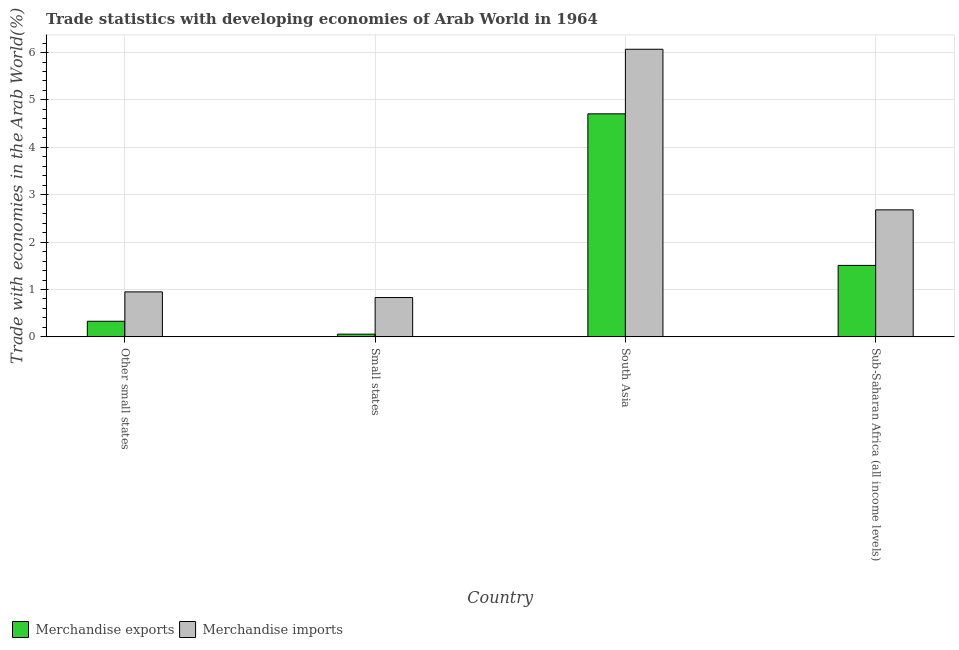How many groups of bars are there?
Provide a succinct answer. 4. How many bars are there on the 1st tick from the right?
Provide a short and direct response. 2. What is the label of the 4th group of bars from the left?
Give a very brief answer. Sub-Saharan Africa (all income levels). What is the merchandise imports in Small states?
Provide a succinct answer. 0.83. Across all countries, what is the maximum merchandise imports?
Your answer should be compact. 6.07. Across all countries, what is the minimum merchandise exports?
Ensure brevity in your answer.  0.06. In which country was the merchandise imports maximum?
Offer a very short reply. South Asia. In which country was the merchandise exports minimum?
Ensure brevity in your answer.  Small states. What is the total merchandise exports in the graph?
Keep it short and to the point. 6.6. What is the difference between the merchandise exports in Small states and that in Sub-Saharan Africa (all income levels)?
Your answer should be very brief. -1.45. What is the difference between the merchandise exports in South Asia and the merchandise imports in Other small states?
Your response must be concise. 3.76. What is the average merchandise imports per country?
Give a very brief answer. 2.63. What is the difference between the merchandise imports and merchandise exports in Small states?
Provide a succinct answer. 0.77. In how many countries, is the merchandise exports greater than 2.8 %?
Make the answer very short. 1. What is the ratio of the merchandise exports in Other small states to that in South Asia?
Your answer should be compact. 0.07. Is the merchandise imports in Small states less than that in South Asia?
Offer a very short reply. Yes. Is the difference between the merchandise exports in Small states and Sub-Saharan Africa (all income levels) greater than the difference between the merchandise imports in Small states and Sub-Saharan Africa (all income levels)?
Keep it short and to the point. Yes. What is the difference between the highest and the second highest merchandise imports?
Give a very brief answer. 3.39. What is the difference between the highest and the lowest merchandise imports?
Offer a very short reply. 5.24. Is the sum of the merchandise imports in Other small states and South Asia greater than the maximum merchandise exports across all countries?
Your answer should be very brief. Yes. Are all the bars in the graph horizontal?
Give a very brief answer. No. Are the values on the major ticks of Y-axis written in scientific E-notation?
Your answer should be compact. No. Does the graph contain any zero values?
Provide a succinct answer. No. Where does the legend appear in the graph?
Give a very brief answer. Bottom left. How are the legend labels stacked?
Provide a succinct answer. Horizontal. What is the title of the graph?
Your answer should be compact. Trade statistics with developing economies of Arab World in 1964. What is the label or title of the Y-axis?
Keep it short and to the point. Trade with economies in the Arab World(%). What is the Trade with economies in the Arab World(%) in Merchandise exports in Other small states?
Your answer should be very brief. 0.33. What is the Trade with economies in the Arab World(%) of Merchandise imports in Other small states?
Your answer should be very brief. 0.95. What is the Trade with economies in the Arab World(%) in Merchandise exports in Small states?
Give a very brief answer. 0.06. What is the Trade with economies in the Arab World(%) of Merchandise imports in Small states?
Give a very brief answer. 0.83. What is the Trade with economies in the Arab World(%) in Merchandise exports in South Asia?
Provide a short and direct response. 4.71. What is the Trade with economies in the Arab World(%) of Merchandise imports in South Asia?
Keep it short and to the point. 6.07. What is the Trade with economies in the Arab World(%) of Merchandise exports in Sub-Saharan Africa (all income levels)?
Make the answer very short. 1.51. What is the Trade with economies in the Arab World(%) in Merchandise imports in Sub-Saharan Africa (all income levels)?
Make the answer very short. 2.68. Across all countries, what is the maximum Trade with economies in the Arab World(%) of Merchandise exports?
Your response must be concise. 4.71. Across all countries, what is the maximum Trade with economies in the Arab World(%) in Merchandise imports?
Provide a succinct answer. 6.07. Across all countries, what is the minimum Trade with economies in the Arab World(%) of Merchandise exports?
Ensure brevity in your answer.  0.06. Across all countries, what is the minimum Trade with economies in the Arab World(%) in Merchandise imports?
Give a very brief answer. 0.83. What is the total Trade with economies in the Arab World(%) in Merchandise exports in the graph?
Your answer should be very brief. 6.6. What is the total Trade with economies in the Arab World(%) in Merchandise imports in the graph?
Your response must be concise. 10.53. What is the difference between the Trade with economies in the Arab World(%) of Merchandise exports in Other small states and that in Small states?
Keep it short and to the point. 0.27. What is the difference between the Trade with economies in the Arab World(%) in Merchandise imports in Other small states and that in Small states?
Offer a terse response. 0.12. What is the difference between the Trade with economies in the Arab World(%) in Merchandise exports in Other small states and that in South Asia?
Provide a short and direct response. -4.38. What is the difference between the Trade with economies in the Arab World(%) of Merchandise imports in Other small states and that in South Asia?
Keep it short and to the point. -5.12. What is the difference between the Trade with economies in the Arab World(%) of Merchandise exports in Other small states and that in Sub-Saharan Africa (all income levels)?
Offer a very short reply. -1.18. What is the difference between the Trade with economies in the Arab World(%) of Merchandise imports in Other small states and that in Sub-Saharan Africa (all income levels)?
Make the answer very short. -1.73. What is the difference between the Trade with economies in the Arab World(%) in Merchandise exports in Small states and that in South Asia?
Your response must be concise. -4.65. What is the difference between the Trade with economies in the Arab World(%) in Merchandise imports in Small states and that in South Asia?
Give a very brief answer. -5.24. What is the difference between the Trade with economies in the Arab World(%) in Merchandise exports in Small states and that in Sub-Saharan Africa (all income levels)?
Your answer should be very brief. -1.45. What is the difference between the Trade with economies in the Arab World(%) of Merchandise imports in Small states and that in Sub-Saharan Africa (all income levels)?
Keep it short and to the point. -1.85. What is the difference between the Trade with economies in the Arab World(%) in Merchandise exports in South Asia and that in Sub-Saharan Africa (all income levels)?
Your response must be concise. 3.2. What is the difference between the Trade with economies in the Arab World(%) in Merchandise imports in South Asia and that in Sub-Saharan Africa (all income levels)?
Provide a short and direct response. 3.39. What is the difference between the Trade with economies in the Arab World(%) in Merchandise exports in Other small states and the Trade with economies in the Arab World(%) in Merchandise imports in Small states?
Your answer should be compact. -0.5. What is the difference between the Trade with economies in the Arab World(%) in Merchandise exports in Other small states and the Trade with economies in the Arab World(%) in Merchandise imports in South Asia?
Give a very brief answer. -5.74. What is the difference between the Trade with economies in the Arab World(%) of Merchandise exports in Other small states and the Trade with economies in the Arab World(%) of Merchandise imports in Sub-Saharan Africa (all income levels)?
Offer a very short reply. -2.35. What is the difference between the Trade with economies in the Arab World(%) in Merchandise exports in Small states and the Trade with economies in the Arab World(%) in Merchandise imports in South Asia?
Offer a very short reply. -6.01. What is the difference between the Trade with economies in the Arab World(%) of Merchandise exports in Small states and the Trade with economies in the Arab World(%) of Merchandise imports in Sub-Saharan Africa (all income levels)?
Ensure brevity in your answer.  -2.62. What is the difference between the Trade with economies in the Arab World(%) of Merchandise exports in South Asia and the Trade with economies in the Arab World(%) of Merchandise imports in Sub-Saharan Africa (all income levels)?
Your response must be concise. 2.03. What is the average Trade with economies in the Arab World(%) of Merchandise exports per country?
Provide a succinct answer. 1.65. What is the average Trade with economies in the Arab World(%) of Merchandise imports per country?
Ensure brevity in your answer.  2.63. What is the difference between the Trade with economies in the Arab World(%) of Merchandise exports and Trade with economies in the Arab World(%) of Merchandise imports in Other small states?
Your response must be concise. -0.62. What is the difference between the Trade with economies in the Arab World(%) in Merchandise exports and Trade with economies in the Arab World(%) in Merchandise imports in Small states?
Provide a short and direct response. -0.77. What is the difference between the Trade with economies in the Arab World(%) in Merchandise exports and Trade with economies in the Arab World(%) in Merchandise imports in South Asia?
Offer a very short reply. -1.36. What is the difference between the Trade with economies in the Arab World(%) in Merchandise exports and Trade with economies in the Arab World(%) in Merchandise imports in Sub-Saharan Africa (all income levels)?
Your answer should be very brief. -1.17. What is the ratio of the Trade with economies in the Arab World(%) in Merchandise exports in Other small states to that in Small states?
Provide a short and direct response. 5.73. What is the ratio of the Trade with economies in the Arab World(%) of Merchandise imports in Other small states to that in Small states?
Your response must be concise. 1.14. What is the ratio of the Trade with economies in the Arab World(%) in Merchandise exports in Other small states to that in South Asia?
Offer a terse response. 0.07. What is the ratio of the Trade with economies in the Arab World(%) in Merchandise imports in Other small states to that in South Asia?
Keep it short and to the point. 0.16. What is the ratio of the Trade with economies in the Arab World(%) of Merchandise exports in Other small states to that in Sub-Saharan Africa (all income levels)?
Offer a very short reply. 0.22. What is the ratio of the Trade with economies in the Arab World(%) of Merchandise imports in Other small states to that in Sub-Saharan Africa (all income levels)?
Offer a terse response. 0.35. What is the ratio of the Trade with economies in the Arab World(%) of Merchandise exports in Small states to that in South Asia?
Give a very brief answer. 0.01. What is the ratio of the Trade with economies in the Arab World(%) of Merchandise imports in Small states to that in South Asia?
Provide a short and direct response. 0.14. What is the ratio of the Trade with economies in the Arab World(%) in Merchandise exports in Small states to that in Sub-Saharan Africa (all income levels)?
Offer a very short reply. 0.04. What is the ratio of the Trade with economies in the Arab World(%) in Merchandise imports in Small states to that in Sub-Saharan Africa (all income levels)?
Offer a terse response. 0.31. What is the ratio of the Trade with economies in the Arab World(%) of Merchandise exports in South Asia to that in Sub-Saharan Africa (all income levels)?
Your response must be concise. 3.12. What is the ratio of the Trade with economies in the Arab World(%) of Merchandise imports in South Asia to that in Sub-Saharan Africa (all income levels)?
Make the answer very short. 2.26. What is the difference between the highest and the second highest Trade with economies in the Arab World(%) of Merchandise exports?
Keep it short and to the point. 3.2. What is the difference between the highest and the second highest Trade with economies in the Arab World(%) of Merchandise imports?
Your answer should be very brief. 3.39. What is the difference between the highest and the lowest Trade with economies in the Arab World(%) of Merchandise exports?
Offer a terse response. 4.65. What is the difference between the highest and the lowest Trade with economies in the Arab World(%) of Merchandise imports?
Make the answer very short. 5.24. 